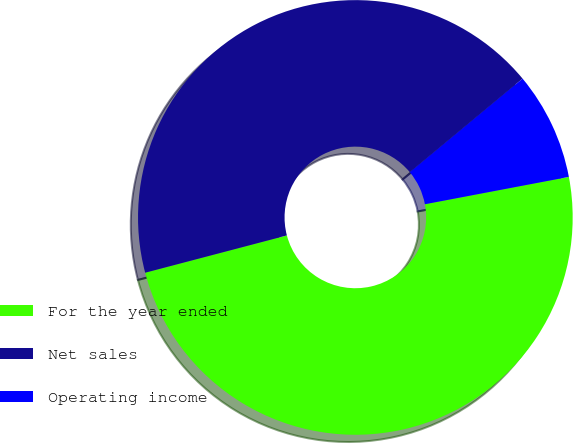Convert chart to OTSL. <chart><loc_0><loc_0><loc_500><loc_500><pie_chart><fcel>For the year ended<fcel>Net sales<fcel>Operating income<nl><fcel>48.9%<fcel>43.07%<fcel>8.04%<nl></chart> 